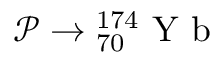Convert formula to latex. <formula><loc_0><loc_0><loc_500><loc_500>\mathcal { P } \rightarrow { _ { 7 0 } ^ { 1 7 4 } } Y b</formula> 